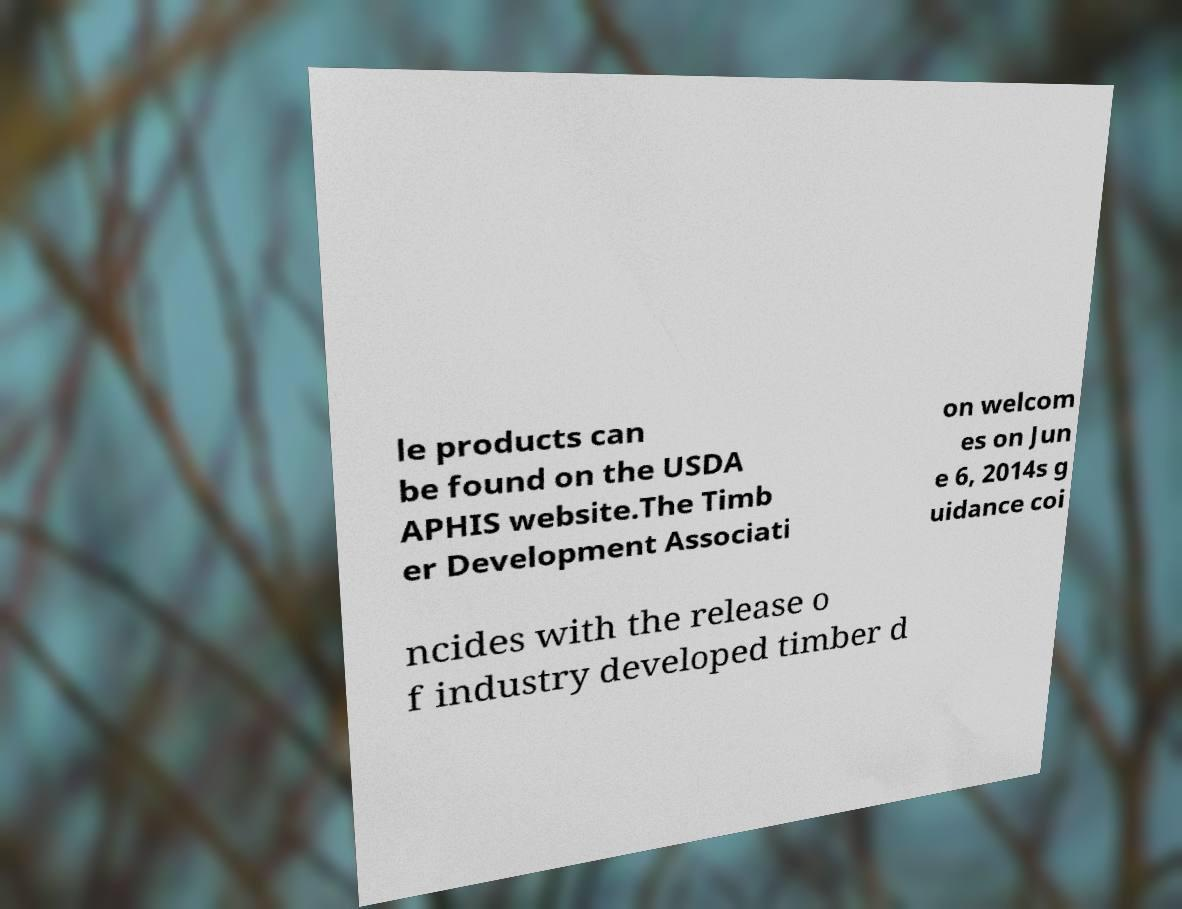Can you accurately transcribe the text from the provided image for me? le products can be found on the USDA APHIS website.The Timb er Development Associati on welcom es on Jun e 6, 2014s g uidance coi ncides with the release o f industry developed timber d 